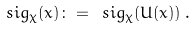<formula> <loc_0><loc_0><loc_500><loc_500>\ s i g _ { \chi } ( x ) \colon = \ s i g _ { \chi } ( U ( x ) ) \, .</formula> 